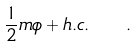<formula> <loc_0><loc_0><loc_500><loc_500>\frac { 1 } { 2 } m \phi + h . c . \quad .</formula> 